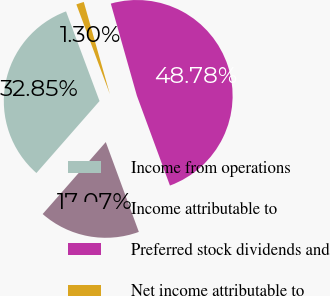Convert chart. <chart><loc_0><loc_0><loc_500><loc_500><pie_chart><fcel>Income from operations<fcel>Income attributable to<fcel>Preferred stock dividends and<fcel>Net income attributable to<nl><fcel>32.85%<fcel>17.07%<fcel>48.78%<fcel>1.3%<nl></chart> 